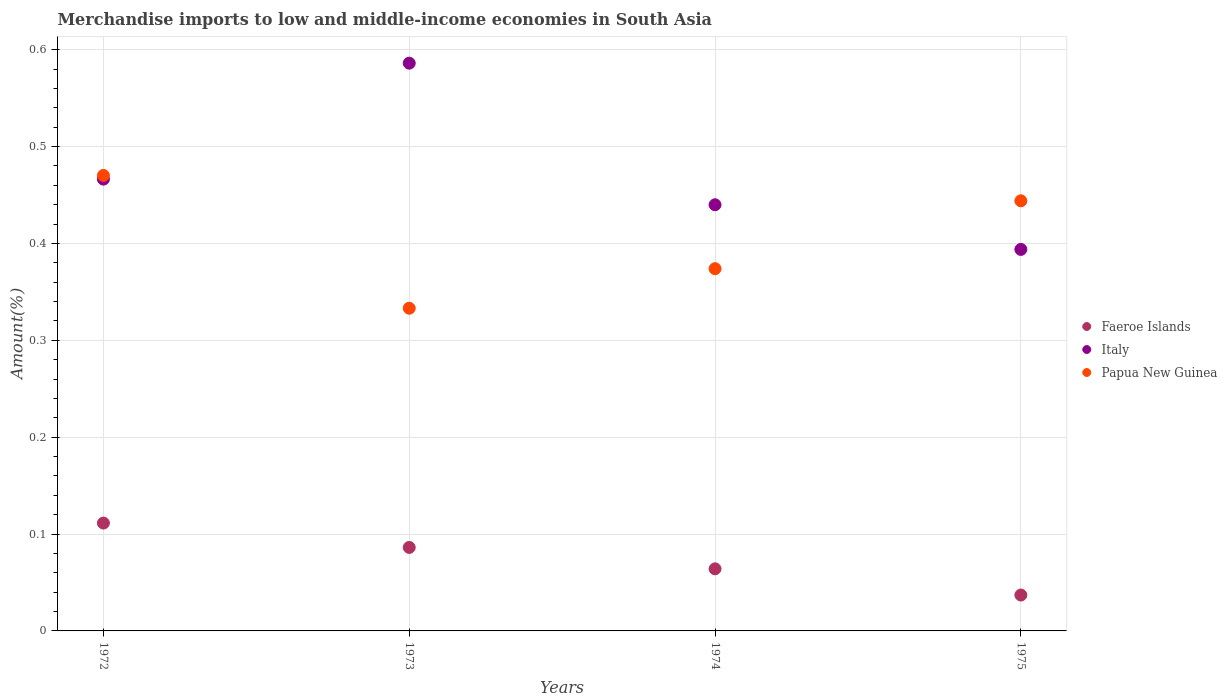How many different coloured dotlines are there?
Provide a succinct answer. 3. Is the number of dotlines equal to the number of legend labels?
Offer a terse response. Yes. What is the percentage of amount earned from merchandise imports in Papua New Guinea in 1974?
Offer a very short reply. 0.37. Across all years, what is the maximum percentage of amount earned from merchandise imports in Italy?
Offer a terse response. 0.59. Across all years, what is the minimum percentage of amount earned from merchandise imports in Italy?
Keep it short and to the point. 0.39. In which year was the percentage of amount earned from merchandise imports in Italy maximum?
Keep it short and to the point. 1973. In which year was the percentage of amount earned from merchandise imports in Italy minimum?
Keep it short and to the point. 1975. What is the total percentage of amount earned from merchandise imports in Faeroe Islands in the graph?
Make the answer very short. 0.3. What is the difference between the percentage of amount earned from merchandise imports in Italy in 1972 and that in 1973?
Keep it short and to the point. -0.12. What is the difference between the percentage of amount earned from merchandise imports in Italy in 1973 and the percentage of amount earned from merchandise imports in Papua New Guinea in 1974?
Provide a succinct answer. 0.21. What is the average percentage of amount earned from merchandise imports in Faeroe Islands per year?
Your answer should be compact. 0.07. In the year 1974, what is the difference between the percentage of amount earned from merchandise imports in Faeroe Islands and percentage of amount earned from merchandise imports in Papua New Guinea?
Make the answer very short. -0.31. In how many years, is the percentage of amount earned from merchandise imports in Italy greater than 0.26 %?
Your answer should be compact. 4. What is the ratio of the percentage of amount earned from merchandise imports in Papua New Guinea in 1973 to that in 1975?
Provide a short and direct response. 0.75. What is the difference between the highest and the second highest percentage of amount earned from merchandise imports in Papua New Guinea?
Keep it short and to the point. 0.03. What is the difference between the highest and the lowest percentage of amount earned from merchandise imports in Italy?
Give a very brief answer. 0.19. In how many years, is the percentage of amount earned from merchandise imports in Papua New Guinea greater than the average percentage of amount earned from merchandise imports in Papua New Guinea taken over all years?
Your response must be concise. 2. Is the sum of the percentage of amount earned from merchandise imports in Italy in 1973 and 1974 greater than the maximum percentage of amount earned from merchandise imports in Faeroe Islands across all years?
Make the answer very short. Yes. What is the difference between two consecutive major ticks on the Y-axis?
Offer a very short reply. 0.1. Where does the legend appear in the graph?
Offer a terse response. Center right. What is the title of the graph?
Make the answer very short. Merchandise imports to low and middle-income economies in South Asia. What is the label or title of the Y-axis?
Your answer should be compact. Amount(%). What is the Amount(%) in Faeroe Islands in 1972?
Your answer should be compact. 0.11. What is the Amount(%) in Italy in 1972?
Offer a terse response. 0.47. What is the Amount(%) of Papua New Guinea in 1972?
Provide a succinct answer. 0.47. What is the Amount(%) in Faeroe Islands in 1973?
Ensure brevity in your answer.  0.09. What is the Amount(%) of Italy in 1973?
Ensure brevity in your answer.  0.59. What is the Amount(%) of Papua New Guinea in 1973?
Offer a very short reply. 0.33. What is the Amount(%) of Faeroe Islands in 1974?
Make the answer very short. 0.06. What is the Amount(%) of Italy in 1974?
Your response must be concise. 0.44. What is the Amount(%) of Papua New Guinea in 1974?
Offer a very short reply. 0.37. What is the Amount(%) of Faeroe Islands in 1975?
Give a very brief answer. 0.04. What is the Amount(%) of Italy in 1975?
Your response must be concise. 0.39. What is the Amount(%) of Papua New Guinea in 1975?
Offer a terse response. 0.44. Across all years, what is the maximum Amount(%) of Faeroe Islands?
Ensure brevity in your answer.  0.11. Across all years, what is the maximum Amount(%) of Italy?
Your response must be concise. 0.59. Across all years, what is the maximum Amount(%) of Papua New Guinea?
Give a very brief answer. 0.47. Across all years, what is the minimum Amount(%) of Faeroe Islands?
Your answer should be very brief. 0.04. Across all years, what is the minimum Amount(%) of Italy?
Your response must be concise. 0.39. Across all years, what is the minimum Amount(%) in Papua New Guinea?
Your answer should be very brief. 0.33. What is the total Amount(%) of Faeroe Islands in the graph?
Offer a terse response. 0.3. What is the total Amount(%) in Italy in the graph?
Keep it short and to the point. 1.89. What is the total Amount(%) in Papua New Guinea in the graph?
Ensure brevity in your answer.  1.62. What is the difference between the Amount(%) in Faeroe Islands in 1972 and that in 1973?
Keep it short and to the point. 0.03. What is the difference between the Amount(%) in Italy in 1972 and that in 1973?
Offer a terse response. -0.12. What is the difference between the Amount(%) in Papua New Guinea in 1972 and that in 1973?
Offer a terse response. 0.14. What is the difference between the Amount(%) of Faeroe Islands in 1972 and that in 1974?
Provide a succinct answer. 0.05. What is the difference between the Amount(%) in Italy in 1972 and that in 1974?
Provide a succinct answer. 0.03. What is the difference between the Amount(%) in Papua New Guinea in 1972 and that in 1974?
Offer a very short reply. 0.1. What is the difference between the Amount(%) of Faeroe Islands in 1972 and that in 1975?
Provide a short and direct response. 0.07. What is the difference between the Amount(%) of Italy in 1972 and that in 1975?
Your response must be concise. 0.07. What is the difference between the Amount(%) in Papua New Guinea in 1972 and that in 1975?
Offer a very short reply. 0.03. What is the difference between the Amount(%) of Faeroe Islands in 1973 and that in 1974?
Keep it short and to the point. 0.02. What is the difference between the Amount(%) of Italy in 1973 and that in 1974?
Your answer should be compact. 0.15. What is the difference between the Amount(%) in Papua New Guinea in 1973 and that in 1974?
Provide a succinct answer. -0.04. What is the difference between the Amount(%) in Faeroe Islands in 1973 and that in 1975?
Your answer should be very brief. 0.05. What is the difference between the Amount(%) in Italy in 1973 and that in 1975?
Offer a terse response. 0.19. What is the difference between the Amount(%) of Papua New Guinea in 1973 and that in 1975?
Keep it short and to the point. -0.11. What is the difference between the Amount(%) of Faeroe Islands in 1974 and that in 1975?
Make the answer very short. 0.03. What is the difference between the Amount(%) of Italy in 1974 and that in 1975?
Provide a succinct answer. 0.05. What is the difference between the Amount(%) in Papua New Guinea in 1974 and that in 1975?
Ensure brevity in your answer.  -0.07. What is the difference between the Amount(%) in Faeroe Islands in 1972 and the Amount(%) in Italy in 1973?
Offer a very short reply. -0.47. What is the difference between the Amount(%) of Faeroe Islands in 1972 and the Amount(%) of Papua New Guinea in 1973?
Make the answer very short. -0.22. What is the difference between the Amount(%) in Italy in 1972 and the Amount(%) in Papua New Guinea in 1973?
Your answer should be compact. 0.13. What is the difference between the Amount(%) in Faeroe Islands in 1972 and the Amount(%) in Italy in 1974?
Give a very brief answer. -0.33. What is the difference between the Amount(%) of Faeroe Islands in 1972 and the Amount(%) of Papua New Guinea in 1974?
Make the answer very short. -0.26. What is the difference between the Amount(%) of Italy in 1972 and the Amount(%) of Papua New Guinea in 1974?
Make the answer very short. 0.09. What is the difference between the Amount(%) of Faeroe Islands in 1972 and the Amount(%) of Italy in 1975?
Offer a very short reply. -0.28. What is the difference between the Amount(%) of Faeroe Islands in 1972 and the Amount(%) of Papua New Guinea in 1975?
Keep it short and to the point. -0.33. What is the difference between the Amount(%) of Italy in 1972 and the Amount(%) of Papua New Guinea in 1975?
Ensure brevity in your answer.  0.02. What is the difference between the Amount(%) in Faeroe Islands in 1973 and the Amount(%) in Italy in 1974?
Provide a short and direct response. -0.35. What is the difference between the Amount(%) of Faeroe Islands in 1973 and the Amount(%) of Papua New Guinea in 1974?
Give a very brief answer. -0.29. What is the difference between the Amount(%) of Italy in 1973 and the Amount(%) of Papua New Guinea in 1974?
Give a very brief answer. 0.21. What is the difference between the Amount(%) in Faeroe Islands in 1973 and the Amount(%) in Italy in 1975?
Your answer should be compact. -0.31. What is the difference between the Amount(%) in Faeroe Islands in 1973 and the Amount(%) in Papua New Guinea in 1975?
Your response must be concise. -0.36. What is the difference between the Amount(%) in Italy in 1973 and the Amount(%) in Papua New Guinea in 1975?
Make the answer very short. 0.14. What is the difference between the Amount(%) in Faeroe Islands in 1974 and the Amount(%) in Italy in 1975?
Offer a terse response. -0.33. What is the difference between the Amount(%) of Faeroe Islands in 1974 and the Amount(%) of Papua New Guinea in 1975?
Your answer should be compact. -0.38. What is the difference between the Amount(%) in Italy in 1974 and the Amount(%) in Papua New Guinea in 1975?
Keep it short and to the point. -0. What is the average Amount(%) of Faeroe Islands per year?
Give a very brief answer. 0.07. What is the average Amount(%) in Italy per year?
Provide a succinct answer. 0.47. What is the average Amount(%) of Papua New Guinea per year?
Ensure brevity in your answer.  0.41. In the year 1972, what is the difference between the Amount(%) in Faeroe Islands and Amount(%) in Italy?
Make the answer very short. -0.36. In the year 1972, what is the difference between the Amount(%) of Faeroe Islands and Amount(%) of Papua New Guinea?
Your answer should be very brief. -0.36. In the year 1972, what is the difference between the Amount(%) in Italy and Amount(%) in Papua New Guinea?
Ensure brevity in your answer.  -0. In the year 1973, what is the difference between the Amount(%) of Faeroe Islands and Amount(%) of Italy?
Make the answer very short. -0.5. In the year 1973, what is the difference between the Amount(%) in Faeroe Islands and Amount(%) in Papua New Guinea?
Offer a terse response. -0.25. In the year 1973, what is the difference between the Amount(%) in Italy and Amount(%) in Papua New Guinea?
Your response must be concise. 0.25. In the year 1974, what is the difference between the Amount(%) in Faeroe Islands and Amount(%) in Italy?
Make the answer very short. -0.38. In the year 1974, what is the difference between the Amount(%) in Faeroe Islands and Amount(%) in Papua New Guinea?
Keep it short and to the point. -0.31. In the year 1974, what is the difference between the Amount(%) in Italy and Amount(%) in Papua New Guinea?
Offer a terse response. 0.07. In the year 1975, what is the difference between the Amount(%) of Faeroe Islands and Amount(%) of Italy?
Provide a short and direct response. -0.36. In the year 1975, what is the difference between the Amount(%) of Faeroe Islands and Amount(%) of Papua New Guinea?
Give a very brief answer. -0.41. In the year 1975, what is the difference between the Amount(%) in Italy and Amount(%) in Papua New Guinea?
Offer a terse response. -0.05. What is the ratio of the Amount(%) in Faeroe Islands in 1972 to that in 1973?
Your response must be concise. 1.29. What is the ratio of the Amount(%) of Italy in 1972 to that in 1973?
Your answer should be very brief. 0.8. What is the ratio of the Amount(%) in Papua New Guinea in 1972 to that in 1973?
Provide a succinct answer. 1.41. What is the ratio of the Amount(%) in Faeroe Islands in 1972 to that in 1974?
Keep it short and to the point. 1.74. What is the ratio of the Amount(%) of Italy in 1972 to that in 1974?
Provide a short and direct response. 1.06. What is the ratio of the Amount(%) of Papua New Guinea in 1972 to that in 1974?
Make the answer very short. 1.26. What is the ratio of the Amount(%) of Faeroe Islands in 1972 to that in 1975?
Your response must be concise. 3.01. What is the ratio of the Amount(%) in Italy in 1972 to that in 1975?
Your response must be concise. 1.18. What is the ratio of the Amount(%) of Papua New Guinea in 1972 to that in 1975?
Your response must be concise. 1.06. What is the ratio of the Amount(%) in Faeroe Islands in 1973 to that in 1974?
Give a very brief answer. 1.34. What is the ratio of the Amount(%) in Italy in 1973 to that in 1974?
Offer a very short reply. 1.33. What is the ratio of the Amount(%) in Papua New Guinea in 1973 to that in 1974?
Give a very brief answer. 0.89. What is the ratio of the Amount(%) in Faeroe Islands in 1973 to that in 1975?
Offer a terse response. 2.33. What is the ratio of the Amount(%) in Italy in 1973 to that in 1975?
Your response must be concise. 1.49. What is the ratio of the Amount(%) in Papua New Guinea in 1973 to that in 1975?
Keep it short and to the point. 0.75. What is the ratio of the Amount(%) in Faeroe Islands in 1974 to that in 1975?
Ensure brevity in your answer.  1.73. What is the ratio of the Amount(%) of Italy in 1974 to that in 1975?
Your response must be concise. 1.12. What is the ratio of the Amount(%) in Papua New Guinea in 1974 to that in 1975?
Provide a succinct answer. 0.84. What is the difference between the highest and the second highest Amount(%) of Faeroe Islands?
Your answer should be very brief. 0.03. What is the difference between the highest and the second highest Amount(%) of Italy?
Give a very brief answer. 0.12. What is the difference between the highest and the second highest Amount(%) of Papua New Guinea?
Give a very brief answer. 0.03. What is the difference between the highest and the lowest Amount(%) of Faeroe Islands?
Offer a very short reply. 0.07. What is the difference between the highest and the lowest Amount(%) of Italy?
Give a very brief answer. 0.19. What is the difference between the highest and the lowest Amount(%) in Papua New Guinea?
Offer a very short reply. 0.14. 